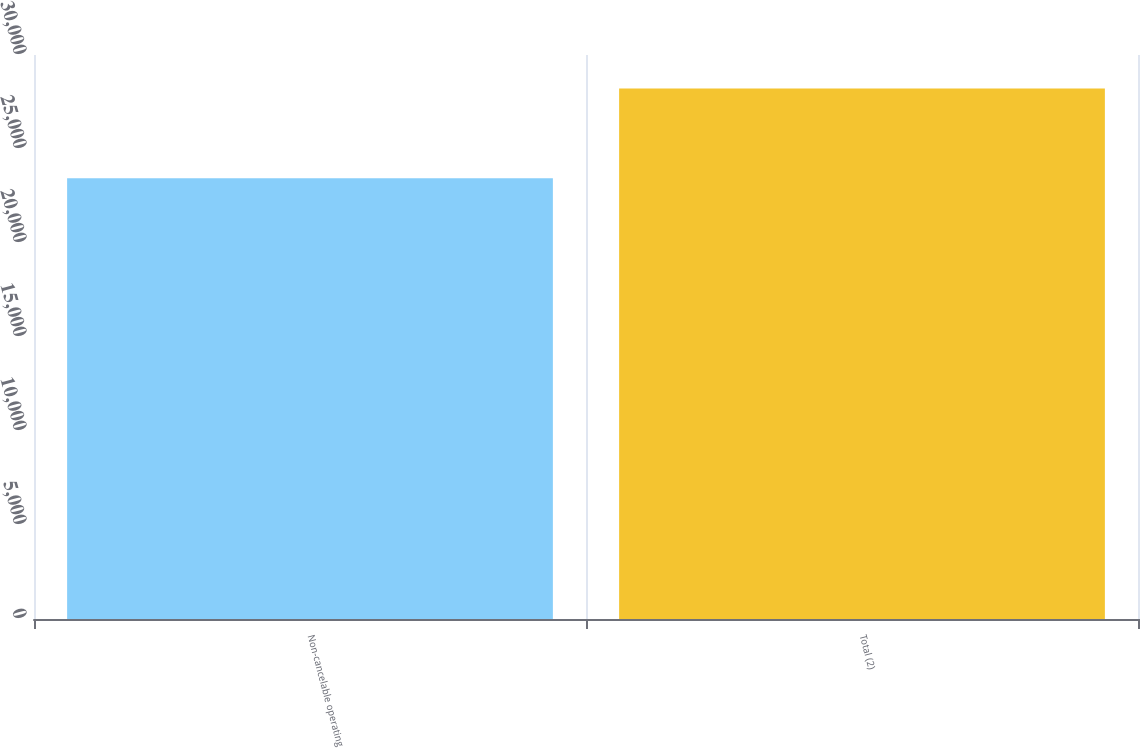Convert chart. <chart><loc_0><loc_0><loc_500><loc_500><bar_chart><fcel>Non-cancelable operating<fcel>Total (2)<nl><fcel>23441<fcel>28218<nl></chart> 